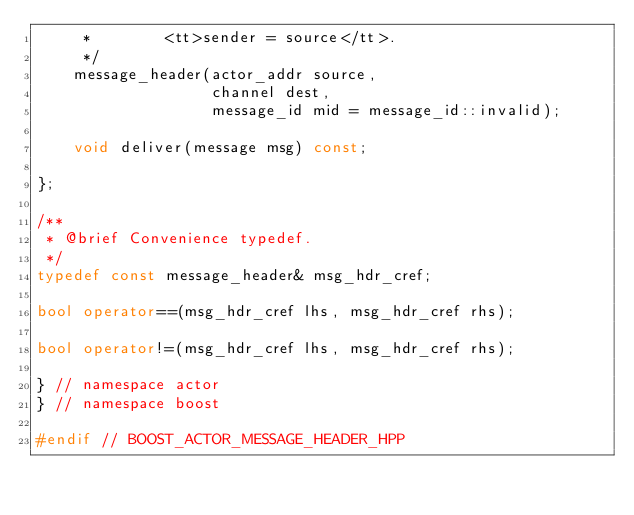<code> <loc_0><loc_0><loc_500><loc_500><_C++_>     *        <tt>sender = source</tt>.
     */
    message_header(actor_addr source,
                   channel dest,
                   message_id mid = message_id::invalid);

    void deliver(message msg) const;

};

/**
 * @brief Convenience typedef.
 */
typedef const message_header& msg_hdr_cref;

bool operator==(msg_hdr_cref lhs, msg_hdr_cref rhs);

bool operator!=(msg_hdr_cref lhs, msg_hdr_cref rhs);

} // namespace actor
} // namespace boost

#endif // BOOST_ACTOR_MESSAGE_HEADER_HPP
</code> 